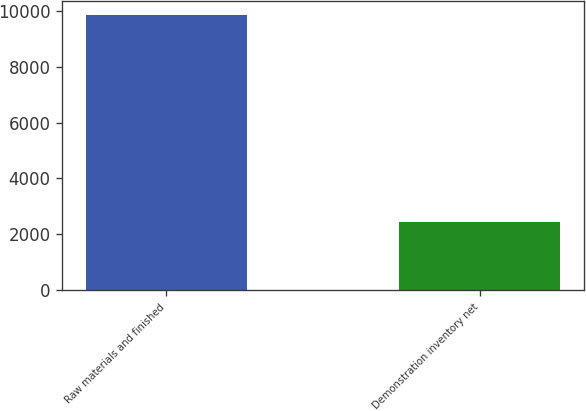Convert chart. <chart><loc_0><loc_0><loc_500><loc_500><bar_chart><fcel>Raw materials and finished<fcel>Demonstration inventory net<nl><fcel>9851<fcel>2433<nl></chart> 